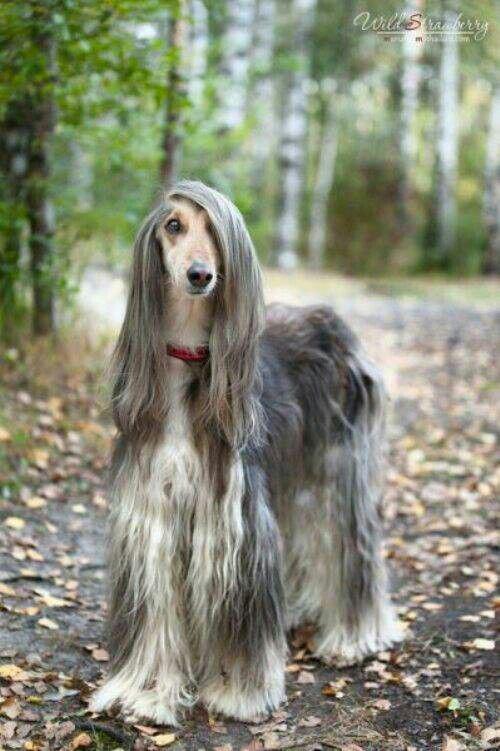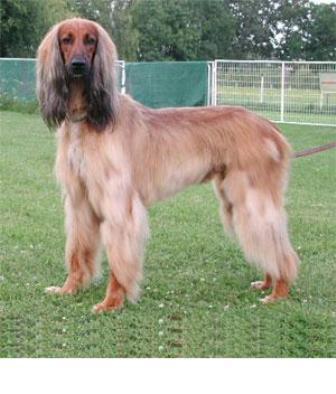The first image is the image on the left, the second image is the image on the right. For the images shown, is this caption "One dog's body is turned to the right, and the other dog's body is turned to the left." true? Answer yes or no. No. The first image is the image on the left, the second image is the image on the right. Given the left and right images, does the statement "The hound on the left is standing and looking forward with its hair combed over one eye, and the hound on the right is standing with its body in profile." hold true? Answer yes or no. Yes. 